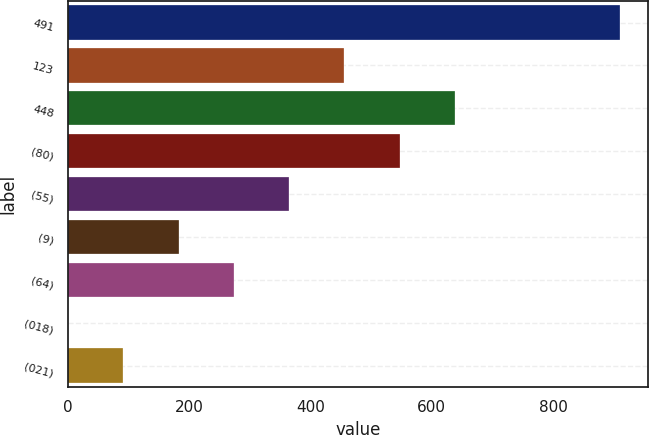<chart> <loc_0><loc_0><loc_500><loc_500><bar_chart><fcel>491<fcel>123<fcel>448<fcel>(80)<fcel>(55)<fcel>(9)<fcel>(64)<fcel>(018)<fcel>(021)<nl><fcel>911<fcel>455.7<fcel>637.82<fcel>546.76<fcel>364.64<fcel>182.52<fcel>273.58<fcel>0.4<fcel>91.46<nl></chart> 